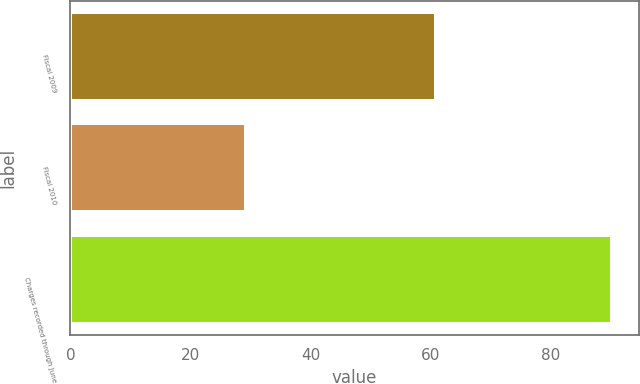Convert chart. <chart><loc_0><loc_0><loc_500><loc_500><bar_chart><fcel>Fiscal 2009<fcel>Fiscal 2010<fcel>Charges recorded through June<nl><fcel>60.9<fcel>29.3<fcel>90.2<nl></chart> 